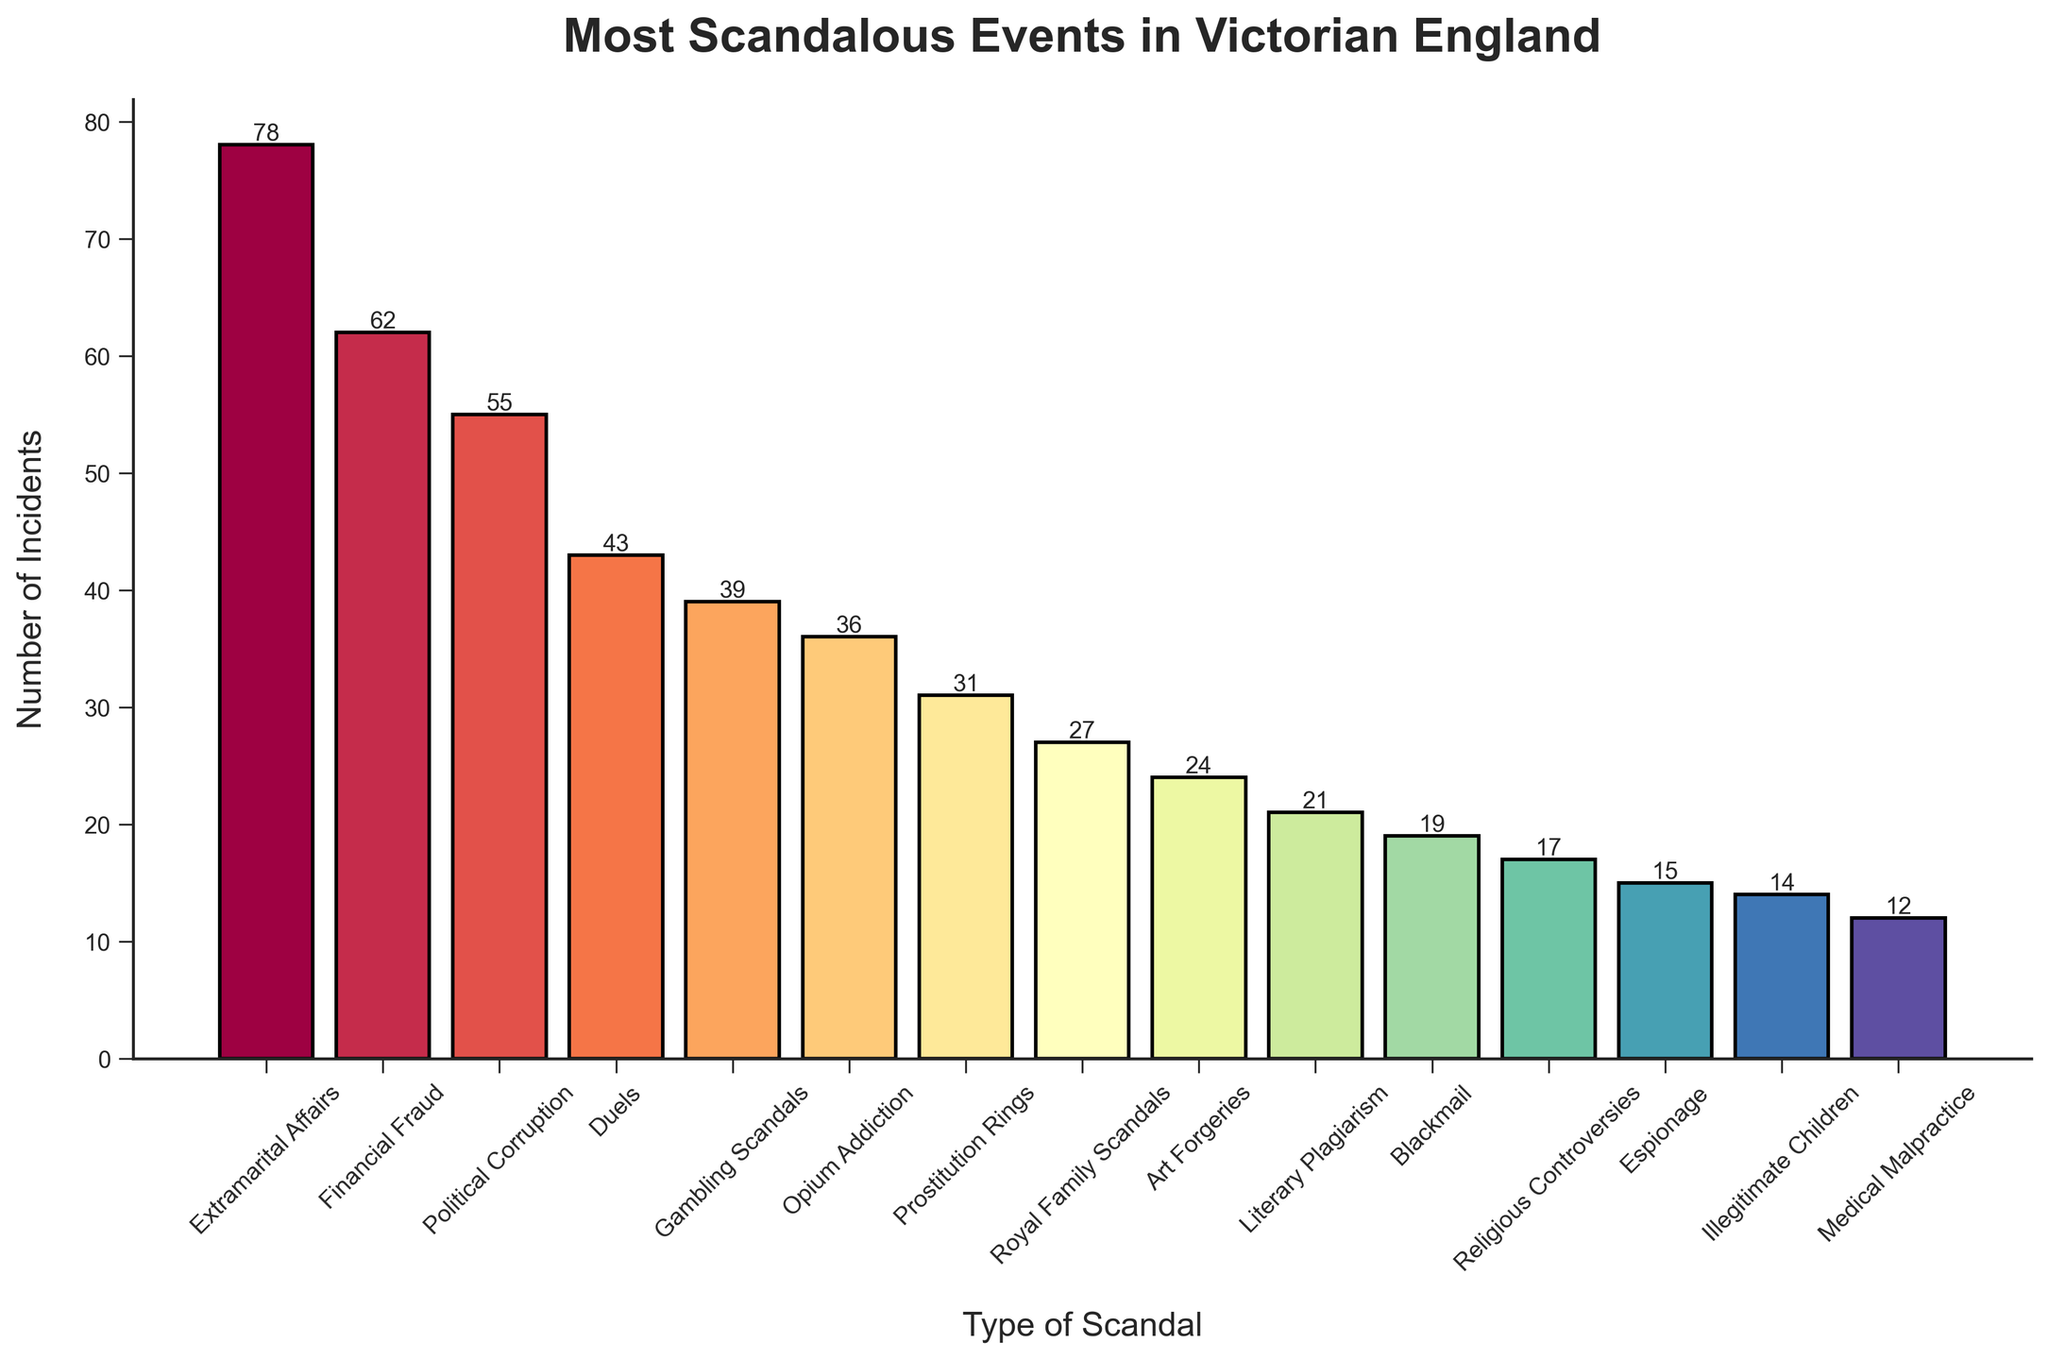Which type of scandal had the highest number of incidents? The figure shows that 'Extramarital Affairs' has the tallest bar, indicating it has the highest number of incidents.
Answer: Extramarital Affairs Which scandals had fewer incidents than 'Political Corruption' but more than 'Opium Addiction'? 'Political Corruption' has 55 incidents, and 'Opium Addiction' has 36 incidents. 'Duels' with 43 incidents and 'Gambling Scandals' with 39 incidents fall in between these two counts.
Answer: Duels, Gambling Scandals How many more incidents of 'Financial Fraud' were there compared to 'Royal Family Scandals'? 'Financial Fraud' had 62 incidents, while 'Royal Family Scandals' had 27 incidents. The difference is 62 - 27 = 35.
Answer: 35 What is the combined number of incidents for 'Religious Controversies' and 'Illegitimate Children'? 'Religious Controversies' had 17 incidents, and 'Illegitimate Children' had 14 incidents. The combined number is 17 + 14 = 31.
Answer: 31 Which scandal type has exactly twice as many incidents as 'Medical Malpractice'? 'Medical Malpractice' had 12 incidents. Doubling that number gives 24 incidents, which corresponds to 'Art Forgeries.'
Answer: Art Forgeries Are there more incidents of 'Literary Plagiarism' or 'Prostitution Rings'? By comparing the heights of the bars, 'Prostitution Rings' had more incidents (31) than 'Literary Plagiarism' (21).
Answer: Prostitution Rings How does the number of 'Blackmail' incidents compare to 'Espionage' incidents? 'Blackmail' had 19 incidents, while 'Espionage' had 15. This means 'Blackmail' incidents are 4 more than 'Espionage' incidents (19 - 15 = 4).
Answer: 4 Which scandal type has the fifth-highest number of incidents? By sorting the bars, the fifth-highest number of incidents corresponds to 'Gambling Scandals' with 39 incidents.
Answer: Gambling Scandals What is the average number of incidents across all types of scandals? The total number of incidents across all types is 475 (sum of all incidents), and there are 15 types. The average is 475 / 15 ≈ 31.67.
Answer: 31.67 What is the median number of incidents for the scandal types? When the incident counts are listed in ascending order (12, 14, 15, 17, 19, 21, 24, 27, 31, 36, 39, 43, 55, 62, 78), the median is the middle value, which is 27.
Answer: 27 